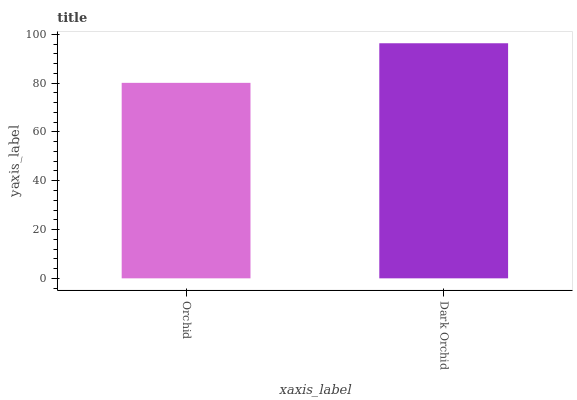Is Orchid the minimum?
Answer yes or no. Yes. Is Dark Orchid the maximum?
Answer yes or no. Yes. Is Dark Orchid the minimum?
Answer yes or no. No. Is Dark Orchid greater than Orchid?
Answer yes or no. Yes. Is Orchid less than Dark Orchid?
Answer yes or no. Yes. Is Orchid greater than Dark Orchid?
Answer yes or no. No. Is Dark Orchid less than Orchid?
Answer yes or no. No. Is Dark Orchid the high median?
Answer yes or no. Yes. Is Orchid the low median?
Answer yes or no. Yes. Is Orchid the high median?
Answer yes or no. No. Is Dark Orchid the low median?
Answer yes or no. No. 